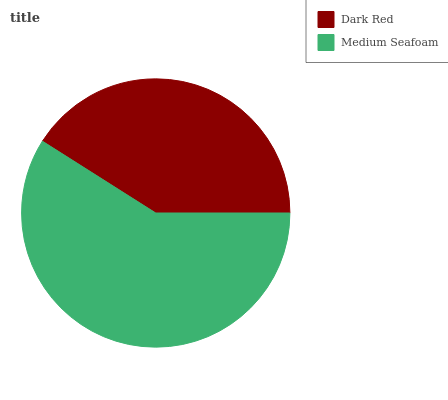Is Dark Red the minimum?
Answer yes or no. Yes. Is Medium Seafoam the maximum?
Answer yes or no. Yes. Is Medium Seafoam the minimum?
Answer yes or no. No. Is Medium Seafoam greater than Dark Red?
Answer yes or no. Yes. Is Dark Red less than Medium Seafoam?
Answer yes or no. Yes. Is Dark Red greater than Medium Seafoam?
Answer yes or no. No. Is Medium Seafoam less than Dark Red?
Answer yes or no. No. Is Medium Seafoam the high median?
Answer yes or no. Yes. Is Dark Red the low median?
Answer yes or no. Yes. Is Dark Red the high median?
Answer yes or no. No. Is Medium Seafoam the low median?
Answer yes or no. No. 